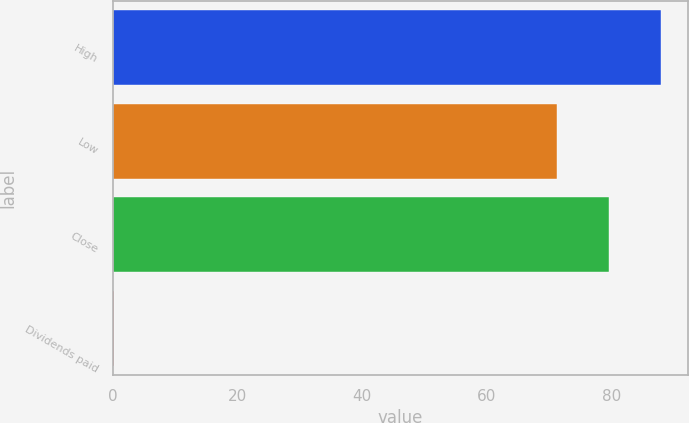<chart> <loc_0><loc_0><loc_500><loc_500><bar_chart><fcel>High<fcel>Low<fcel>Close<fcel>Dividends paid<nl><fcel>87.91<fcel>71.29<fcel>79.6<fcel>0.25<nl></chart> 